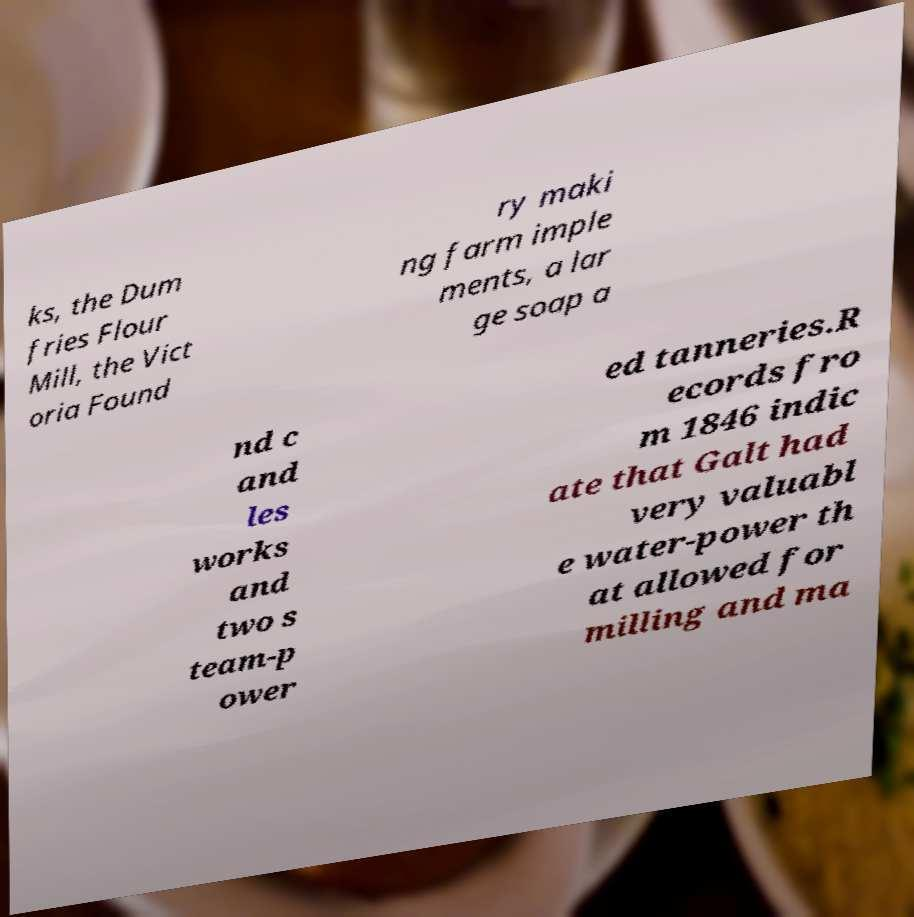Please identify and transcribe the text found in this image. ks, the Dum fries Flour Mill, the Vict oria Found ry maki ng farm imple ments, a lar ge soap a nd c and les works and two s team-p ower ed tanneries.R ecords fro m 1846 indic ate that Galt had very valuabl e water-power th at allowed for milling and ma 